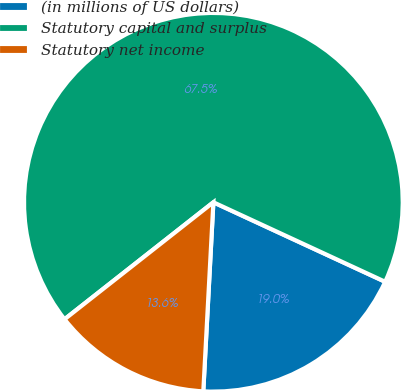Convert chart to OTSL. <chart><loc_0><loc_0><loc_500><loc_500><pie_chart><fcel>(in millions of US dollars)<fcel>Statutory capital and surplus<fcel>Statutory net income<nl><fcel>18.95%<fcel>67.5%<fcel>13.55%<nl></chart> 